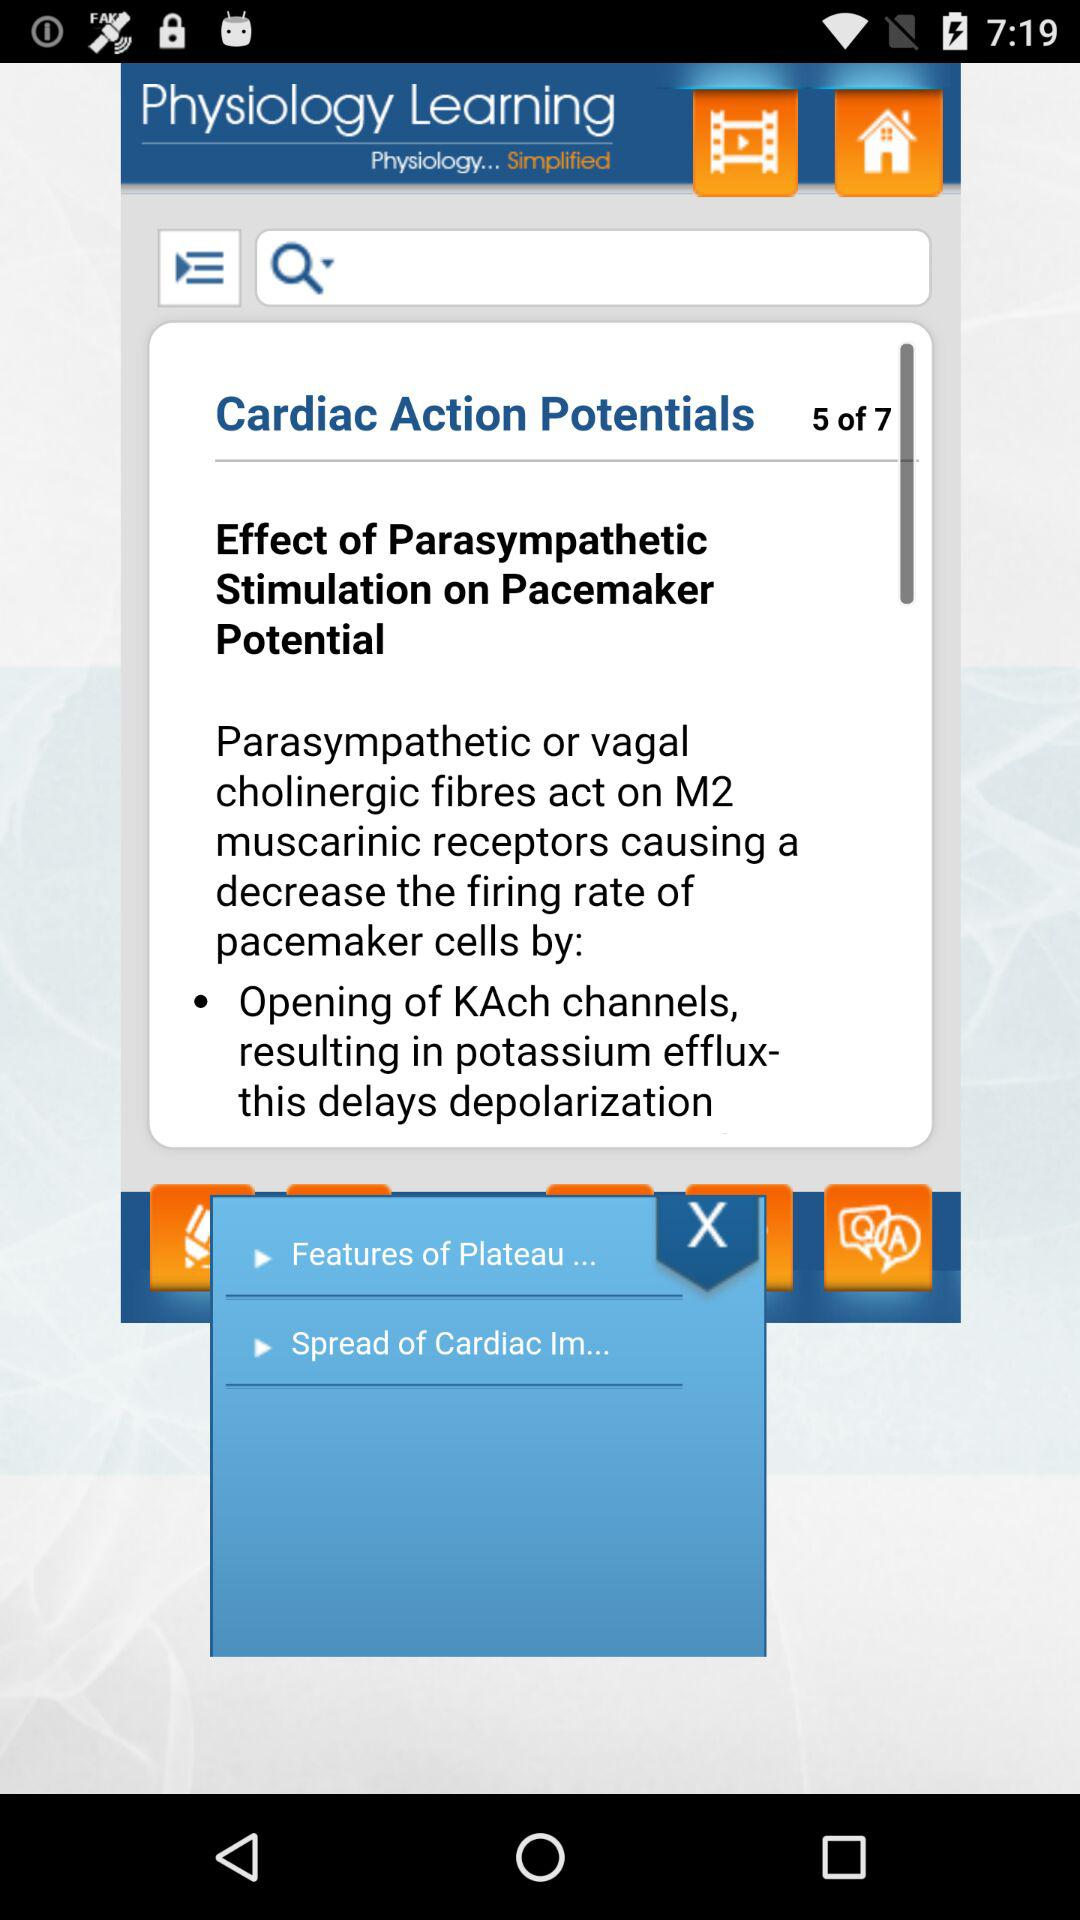How many pages are there for "Cardiac Action Potentials"? There are 7 pages for "Cardiac Action Potentials". 